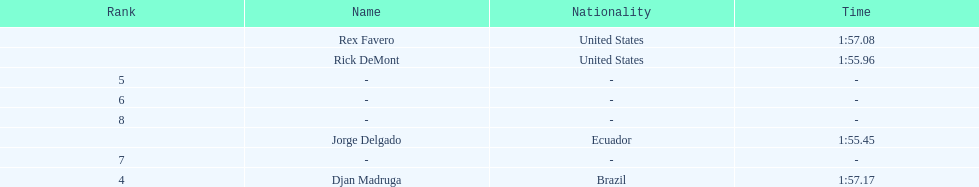What is the average time? 1:56.42. 